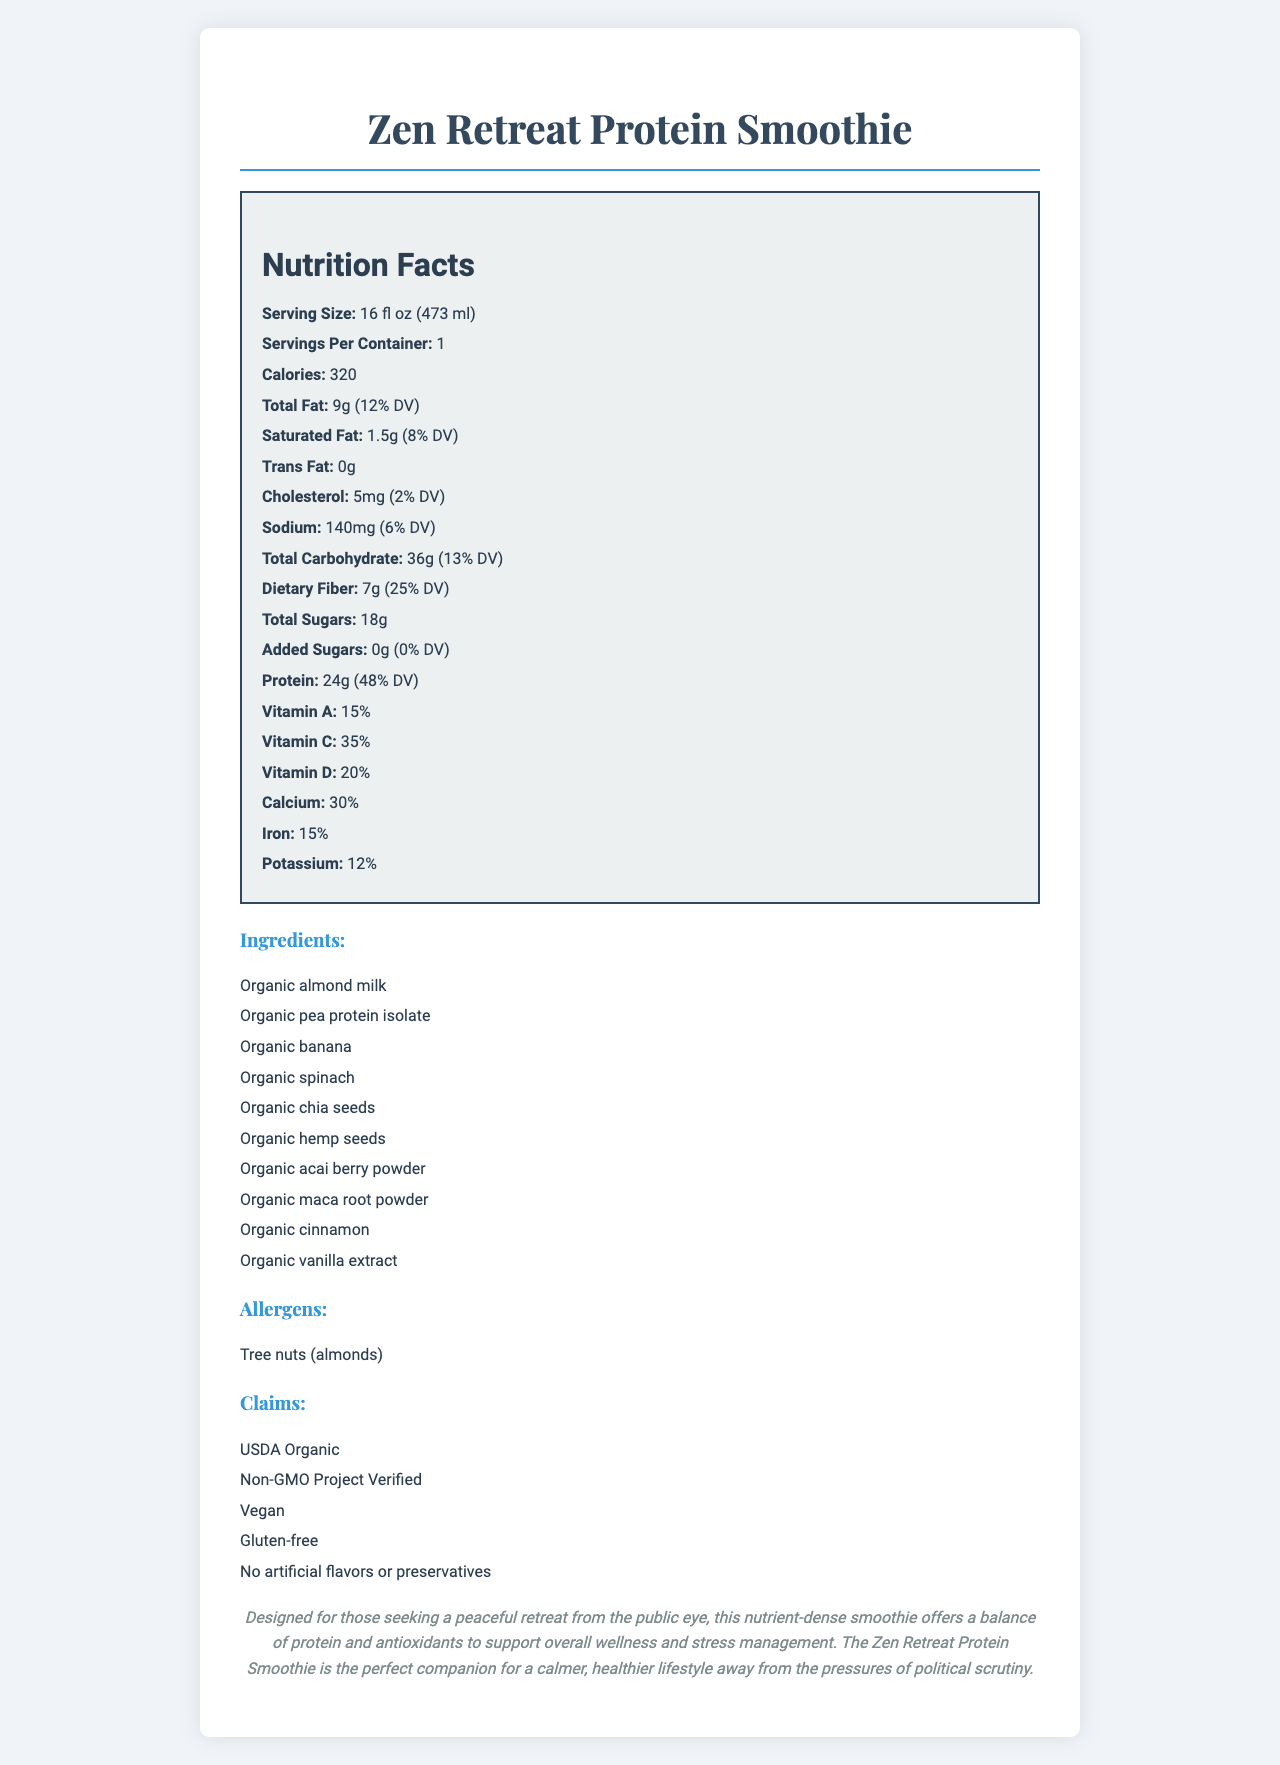what is the serving size of the Zen Retreat Protein Smoothie? The serving size is clearly specified under the nutrition facts section as "16 fl oz (473 ml)".
Answer: 16 fl oz (473 ml) how many grams of protein are in the Zen Retreat Protein Smoothie? The protein content is listed under the "Protein" subheading in the nutrition facts section as "24g".
Answer: 24g what vitamins are included in the Zen Retreat Protein Smoothie? The vitamins are listed under the nutrition facts section with their respective daily values: Vitamin A (15%), Vitamin C (35%), and Vitamin D (20%).
Answer: Vitamin A, Vitamin C, Vitamin D how much dietary fiber does the smoothie provide per serving? The dietary fiber content is listed as "7g" in the nutrition facts section.
Answer: 7g what allergen is specified for this smoothie? The allergens listed in the document specify "Tree nuts (almonds)".
Answer: Tree nuts (almonds) what is the total number of calories in one serving of the Zen Retreat Protein Smoothie? The calorie count is clearly indicated as "320" under the nutrition facts section.
Answer: 320 which claim is NOT associated with the Zen Retreat Protein Smoothie? A. USDA Organic B. Non-GMO Project Verified C. Contains Dairy D. Vegan The claims listed include USDA Organic, Non-GMO Project Verified, Vegan, Gluten-free, and No artificial flavors or preservatives, but not "Contains Dairy".
Answer: C. Contains Dairy how much saturated fat is in the Zen Retreat Protein Smoothie? A. 0g B. 1g C. 1.5g D. 2g The amount of saturated fat is listed as "1.5g" in the nutrition facts section.
Answer: C. 1.5g is the Zen Retreat Protein Smoothie gluten-free? One of the claims in the document states that the product is "Gluten-free".
Answer: Yes describe the main idea of the document. The document mainly focuses on giving a comprehensive overview of the Zen Retreat Protein Smoothie, covering its nutritional content, ingredient list, and claims, framed with an emphasis on health and wellness benefits.
Answer: The document provides detailed nutrition information about the Zen Retreat Protein Smoothie, including serving size, calorie count, nutrient breakdown, ingredients, allergens, and various product claims. It also includes a personalized description highlighting the smoothie as a nutrient-dense option for those seeking a healthier lifestyle. how much Vitamin E does the Zen Retreat Protein Smoothie contain? The document does not list the content of Vitamin E, hence it cannot be determined from the given information.
Answer: Cannot be determined 